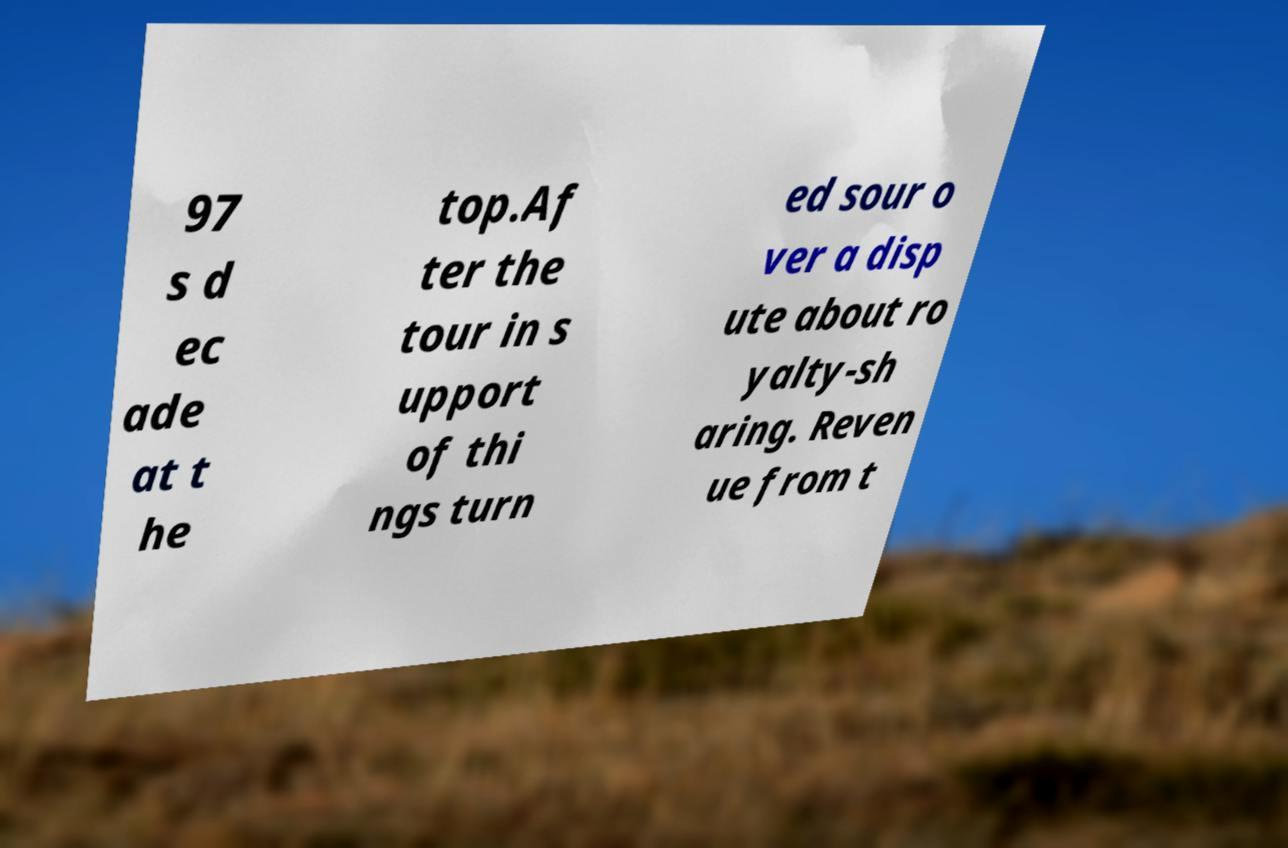Can you read and provide the text displayed in the image?This photo seems to have some interesting text. Can you extract and type it out for me? 97 s d ec ade at t he top.Af ter the tour in s upport of thi ngs turn ed sour o ver a disp ute about ro yalty-sh aring. Reven ue from t 